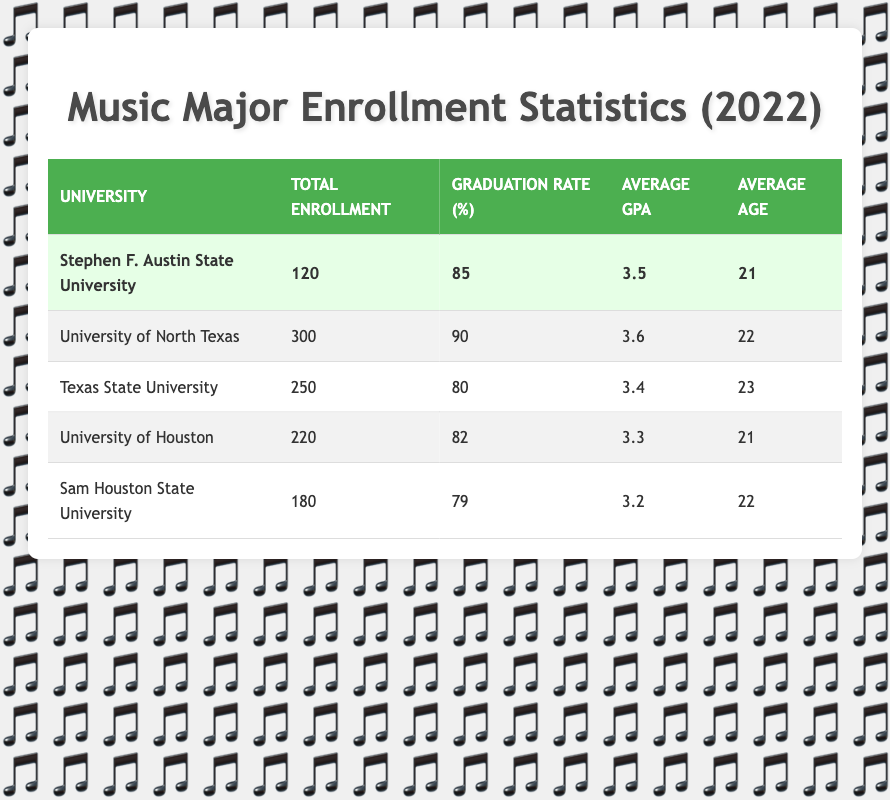What is the total enrollment for Stephen F. Austin State University? The table lists the total enrollment for Stephen F. Austin State University as 120.
Answer: 120 Which university has the highest graduation rate? According to the table, the University of North Texas has the highest graduation rate at 90%.
Answer: 90 What is the average GPA of music majors at Texas State University? The table shows that the average GPA of music majors at Texas State University is 3.4.
Answer: 3.4 How many students are enrolled in total across all universities listed? To find the total enrollment across all universities, we add 120 (SFA) + 300 (UNT) + 250 (TX State) + 220 (UH) + 180 (Sam Houston) = 1070.
Answer: 1070 Is the average age of music majors at the University of Houston higher than 21? The University of Houston has an average age of 21, which is not higher than 21. Therefore, the answer is no.
Answer: No What is the difference in graduation rates between Texas State University and Sam Houston State University? The graduation rate for Texas State University is 80% and for Sam Houston State University is 79%. The difference is 80 - 79 = 1%.
Answer: 1% Which universities have an average GPA higher than 3.5? Reviewing the table, the University of North Texas (3.6) is the only university with an average GPA higher than 3.5.
Answer: University of North Texas What is the average age of music majors across all five universities? The average age can be calculated by summing the average ages: (21 + 22 + 23 + 21 + 22) / 5 = 21.8, which rounds to approximately 22.
Answer: 22 Does Stephen F. Austin State University have a lower graduation rate than Sam Houston State University? Stephen F. Austin's graduation rate is 85%, which is higher than Sam Houston State's rate of 79%. Therefore, the answer is no.
Answer: No 